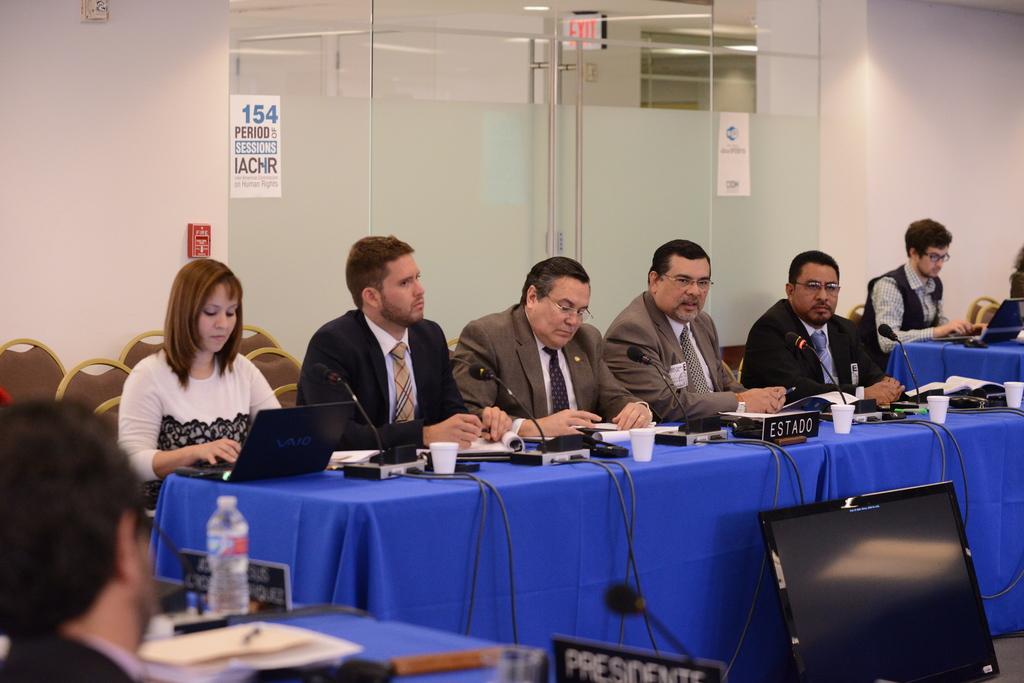Who is sitting in the left bottom corner of the photo?
Make the answer very short. President. What is the title of the person in the bottom middle area?
Give a very brief answer. President. 